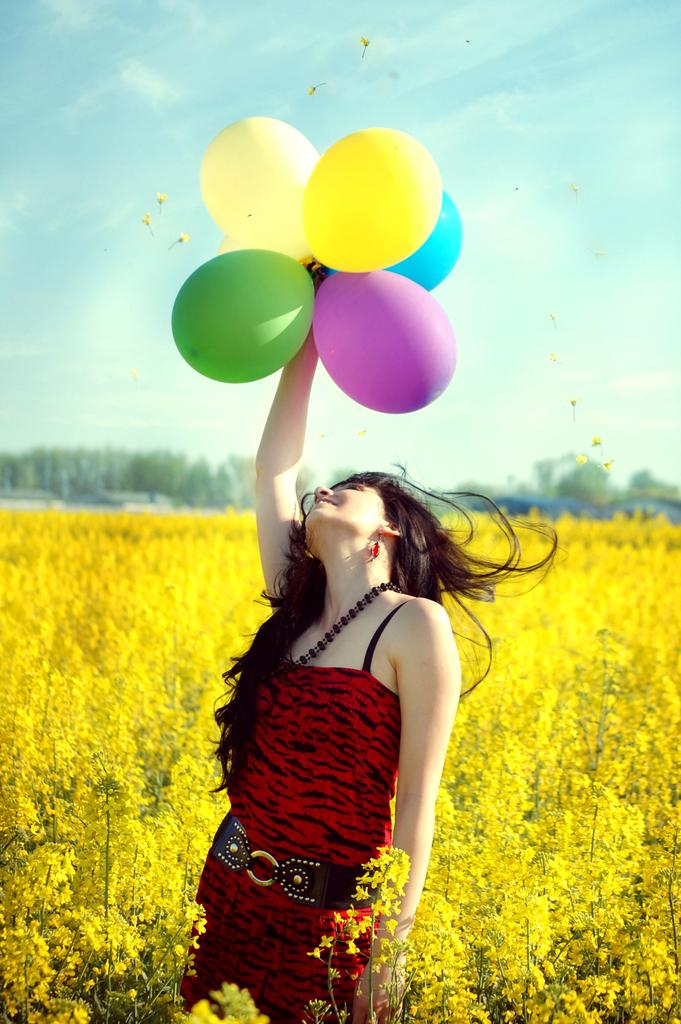What is the woman in the image holding? The woman is holding balloons. What type of vegetation can be seen in the image? There is a group of plants with flowers and trees in the image. What type of structures are visible in the image? There are houses in the image. What is visible in the sky in the image? The sky is visible in the image and appears cloudy. What type of doll can be seen playing with a tank in the image? There is no doll or tank present in the image. What type of pleasure can be derived from the image? The image does not convey a specific pleasure or emotion; it is a neutral representation of the scene. 